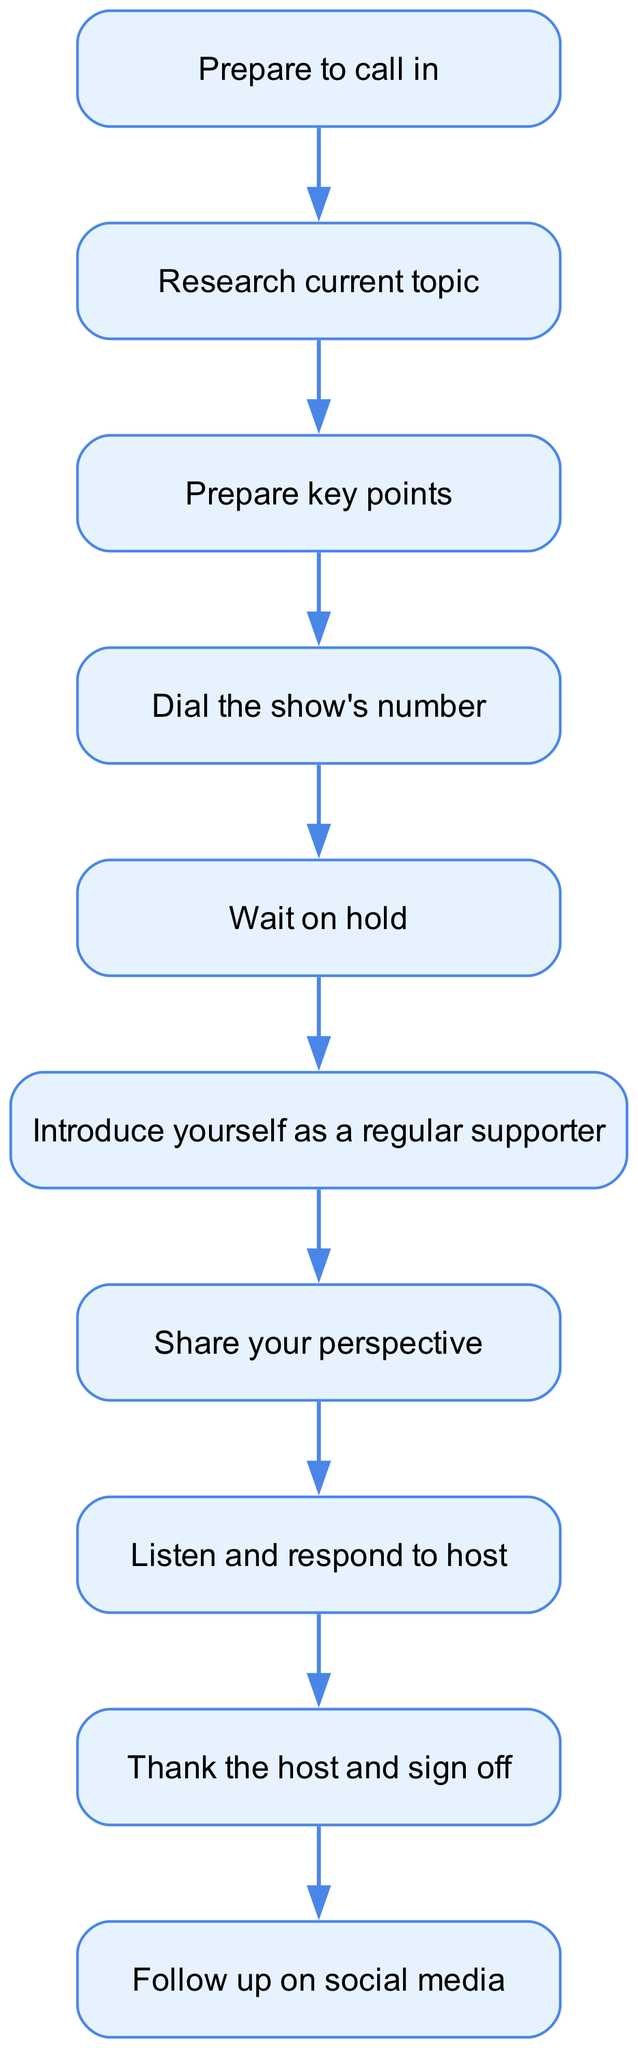What is the first step in the flow chart? The flow chart begins with the node labeled "Prepare to call in," which is the starting point of the process.
Answer: Prepare to call in How many nodes are there in total? By counting all the unique elements in the diagram, there are ten distinct nodes identified in the flow chart.
Answer: 10 What is the last action to take as per the flow chart? The final action indicated in the flow chart is to "Follow up on social media," which comes after thanking the host and signing off.
Answer: Follow up on social media What connects "Dial the show's number" to "Wait on hold"? The connection between "Dial the show's number" and "Wait on hold" is represented by a directional edge indicating the flow of the process, showing that once the number is dialed, the next step is to wait.
Answer: An edge What step follows after "Introduce yourself as a regular supporter"? Following the introduction, the next action in the flow chart is to "Share your perspective," indicating that the person's input comes after they have introduced themselves.
Answer: Share your perspective How does one transition from "Listen and respond to host" to the end of the call? The transition from "Listen and respond to host" to the end of the call is made through the directed flow that indicates the last step before concluding the call is listening and responding, which then leads to thanking the host.
Answer: Through a directed flow 